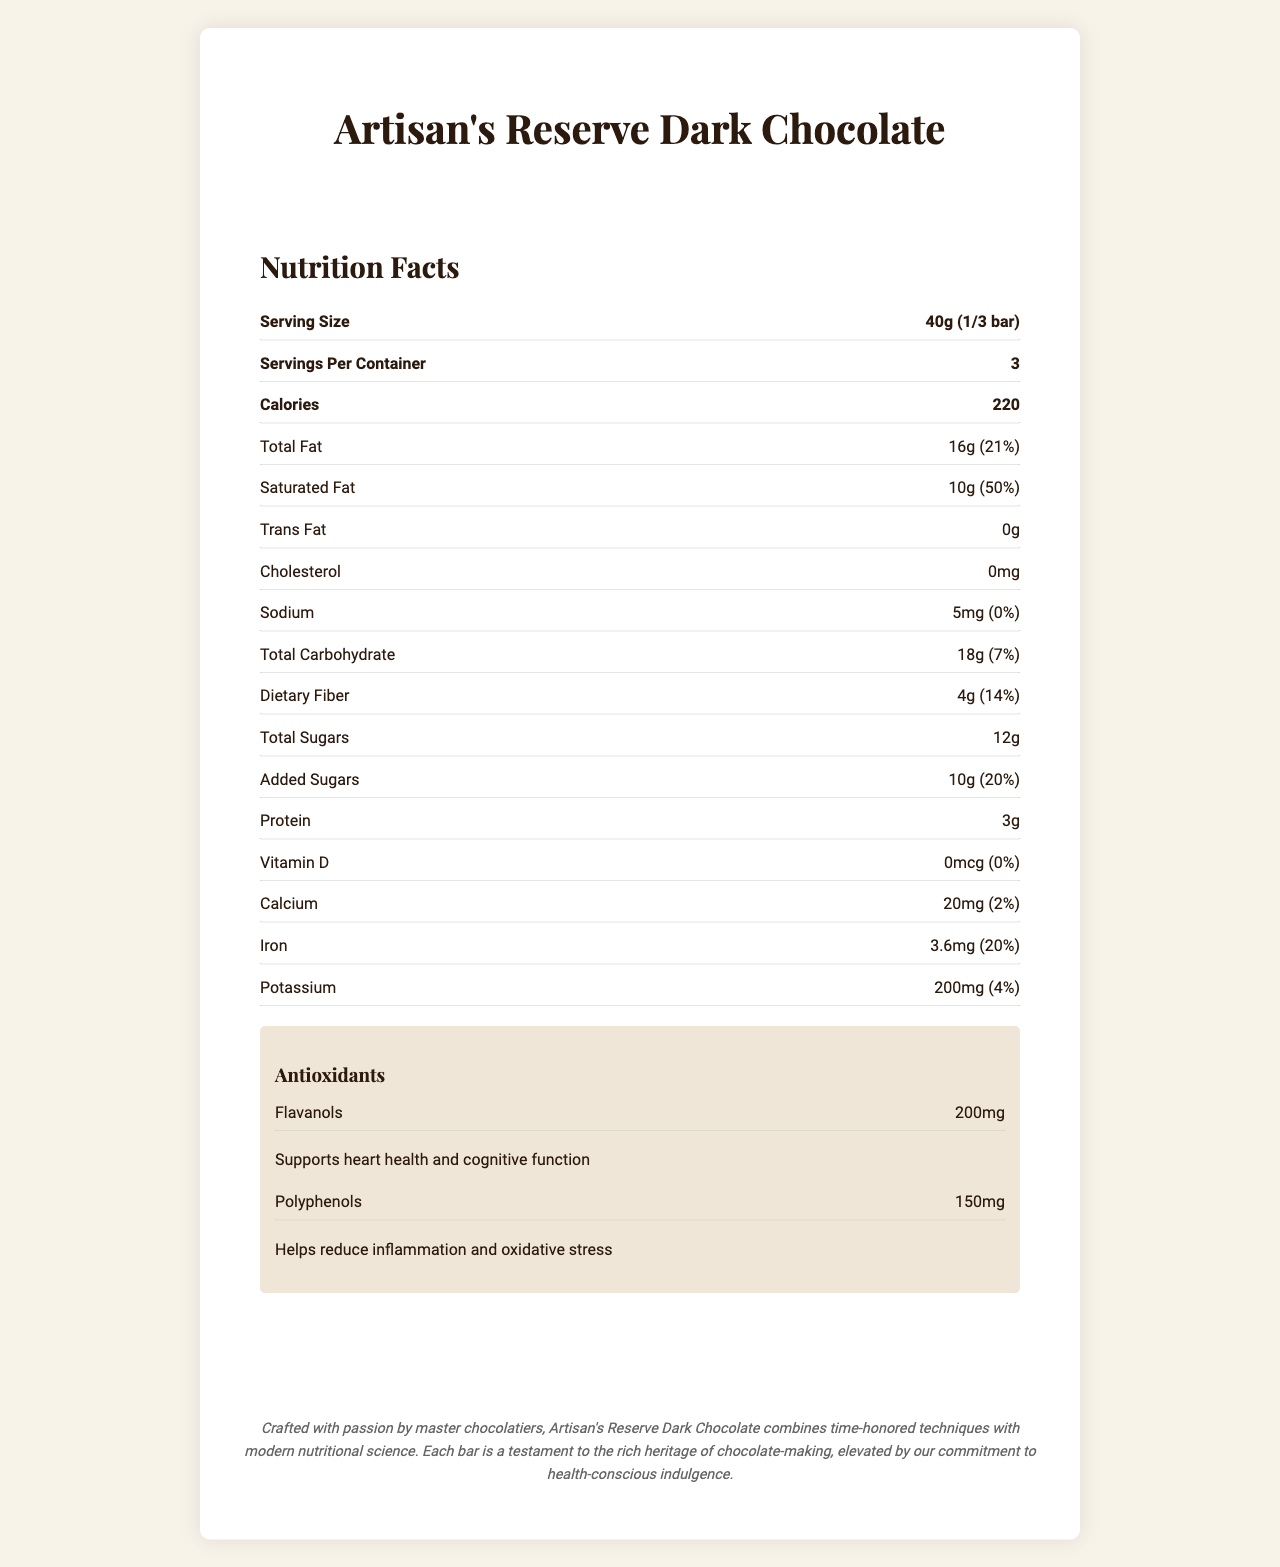What is the serving size of Artisan's Reserve Dark Chocolate? The serving size can be found under "Serving Size" in the nutrition facts.
Answer: 40g (1/3 bar) How many calories are there per serving of the chocolate? The number of calories per serving is listed under "Calories" in the nutrition facts.
Answer: 220 calories What percentage of the daily value for saturated fat does one serving provide? The percentage daily value for saturated fat is shown next to the amount of saturated fat in the nutrition facts.
Answer: 50% How much total carbohydrate is in one serving? The amount of total carbohydrate per serving is listed under "Total Carbohydrate" in the nutrition facts.
Answer: 18g What are the antioxidant components present in the chocolate, and what are their benefits? The antioxidants section details that flavanols support heart health and cognitive function, while polyphenols help reduce inflammation and oxidative stress.
Answer: Flavanols and Polyphenols How many servings are in one container of the chocolate bar? The servings per container is listed right under the serving size in the nutrition facts.
Answer: 3 Which vitamin is not present in the Artisan's Reserve Dark Chocolate? A. Vitamin A B. Vitamin C C. Vitamin D D. Vitamin E The nutrition facts state that Vitamin D is present in 0mcg, indicating its absence.
Answer: C. Vitamin D Which of the following certifications does the Artisan's Reserve Dark Chocolate hold? A. USDA Organic B. Rainforest Alliance Certified C. Vegan D. Kosher The certifications listed in the document include USDA Organic, but not the other options.
Answer: A. USDA Organic Is the dark chocolate bar crafted in large batches? The special features specify that it is "Small-batch crafted", indicating it is not made in large quantities.
Answer: No Summarize the main features and nutritional benefits of Artisan's Reserve Dark Chocolate. This summary covers the product's main characteristics, nutritional content, and certifications based on the information provided in the document.
Answer: Artisan's Reserve Dark Chocolate is a premium product with a rich heritage, crafted with single-origin Ecuadorian cacao in small batches. It is rich in antioxidants like flavanols and polyphenols, which support heart health and reduce inflammation. It has 220 calories per serving, with significant amounts of fat, fiber, and iron, and it's certified USDA Organic, Fair Trade, and Non-GMO. What is the main color theme of the product's design? The design elements section specifies that the primary color is deep burgundy with metallic gold accents.
Answer: Deep burgundy and metallic gold What are the ingredient sources for the Artisan's Reserve Dark Chocolate? The document lists the ingredients but doesn't provide specific source details beyond "organic" and "single-origin Ecuadorian cacao".
Answer: Cannot be determined Are there any allergens present in the chocolate? The allergen information section states that the chocolate may contain traces of nuts and milk.
Answer: May contain traces of nuts and milk 